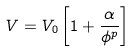<formula> <loc_0><loc_0><loc_500><loc_500>V = V _ { 0 } \left [ 1 + \frac { \alpha } { \phi ^ { p } } \right ]</formula> 